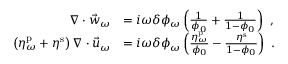<formula> <loc_0><loc_0><loc_500><loc_500>\begin{array} { r l } { \nabla \cdot \vec { w } _ { \omega } } & { = i \omega \delta \phi _ { \omega } \left ( \frac { 1 } { \phi _ { 0 } } + \frac { 1 } { 1 - \phi _ { 0 } } \right ) \ , } \\ { \left ( \eta _ { \omega } ^ { p } + \eta ^ { s } \right ) \nabla \cdot \vec { u } _ { \omega } } & { = i \omega \delta \phi _ { \omega } \left ( \frac { \eta _ { \omega } ^ { p } } { \phi _ { 0 } } - \frac { \eta ^ { s } } { 1 - \phi _ { 0 } } \right ) \ . } \end{array}</formula> 